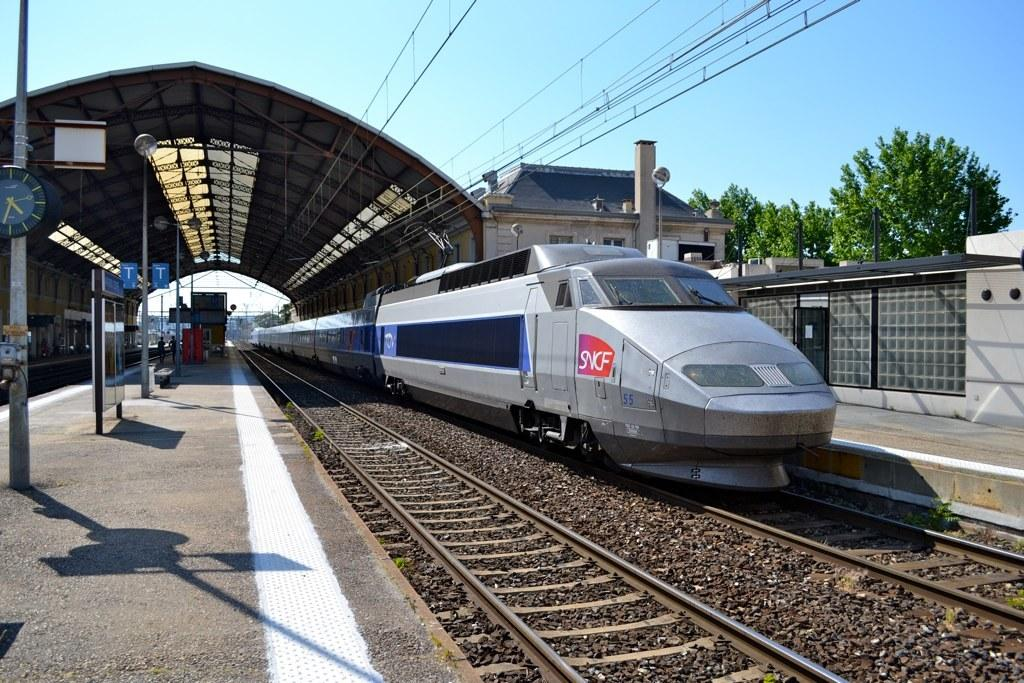Provide a one-sentence caption for the provided image. A silver train with a logo in red which reads SNCF on the front. 